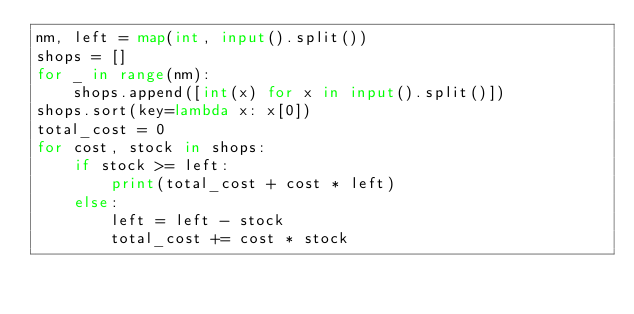<code> <loc_0><loc_0><loc_500><loc_500><_Python_>nm, left = map(int, input().split())
shops = []
for _ in range(nm):
    shops.append([int(x) for x in input().split()])
shops.sort(key=lambda x: x[0])
total_cost = 0
for cost, stock in shops:
    if stock >= left:
        print(total_cost + cost * left)
    else:
        left = left - stock
        total_cost += cost * stock
</code> 